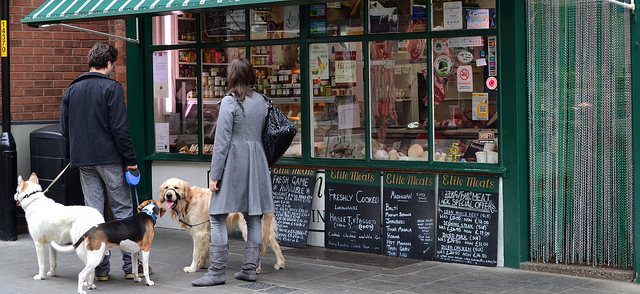What type of animals are shown?
A. aquatic
B. wild
C. domestic
D. stuffed Based on the visible leashes and the presence of people with them, the animals in the image are domestic dogs. Dogs are commonly kept as pets and are dependent on humans for care, which classifies them as domestic animals. 